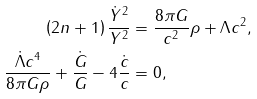Convert formula to latex. <formula><loc_0><loc_0><loc_500><loc_500>\left ( 2 n + 1 \right ) \frac { \dot { Y } ^ { 2 } } { Y ^ { 2 } } & = \frac { 8 \pi G } { c ^ { 2 } } \rho + \Lambda c ^ { 2 } , \\ \frac { \dot { \Lambda } c ^ { 4 } } { 8 \pi G \rho } + \frac { \dot { G } } { G } - 4 \frac { \dot { c } } { c } & = 0 ,</formula> 